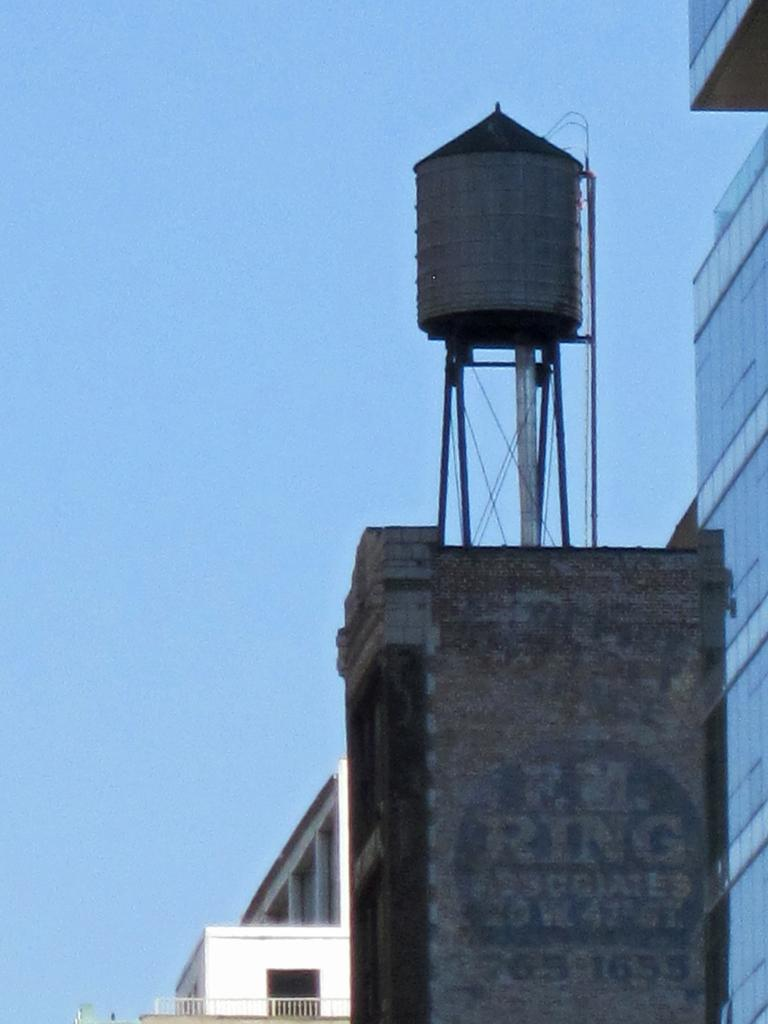What is located on top of the building in the image? There is a tank on top of a building in the image. What is the color of the sky in the image? The sky is blue in the image. What type of volleyball game is being played in the image? There is no volleyball game present in the image. What color is the cap worn by the person in the image? There is no person or cap visible in the image. 